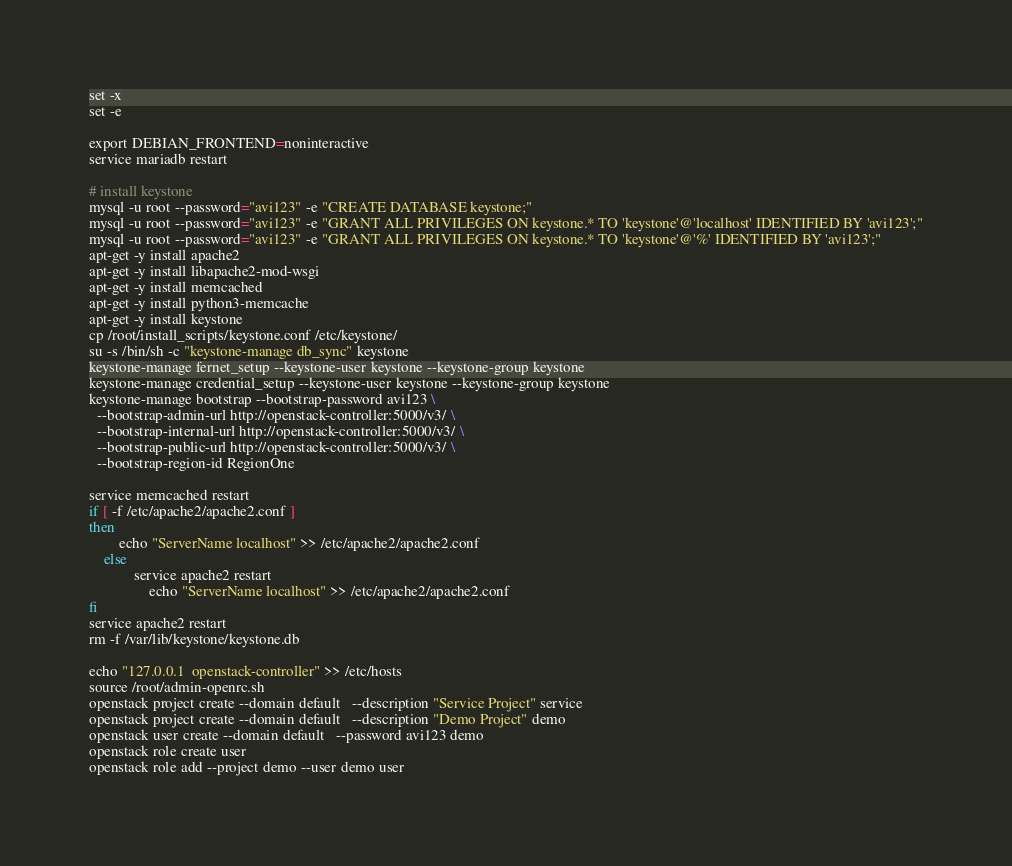Convert code to text. <code><loc_0><loc_0><loc_500><loc_500><_Bash_>set -x
set -e

export DEBIAN_FRONTEND=noninteractive
service mariadb restart

# install keystone
mysql -u root --password="avi123" -e "CREATE DATABASE keystone;"
mysql -u root --password="avi123" -e "GRANT ALL PRIVILEGES ON keystone.* TO 'keystone'@'localhost' IDENTIFIED BY 'avi123';"
mysql -u root --password="avi123" -e "GRANT ALL PRIVILEGES ON keystone.* TO 'keystone'@'%' IDENTIFIED BY 'avi123';"
apt-get -y install apache2
apt-get -y install libapache2-mod-wsgi
apt-get -y install memcached
apt-get -y install python3-memcache
apt-get -y install keystone
cp /root/install_scripts/keystone.conf /etc/keystone/
su -s /bin/sh -c "keystone-manage db_sync" keystone
keystone-manage fernet_setup --keystone-user keystone --keystone-group keystone
keystone-manage credential_setup --keystone-user keystone --keystone-group keystone
keystone-manage bootstrap --bootstrap-password avi123 \
  --bootstrap-admin-url http://openstack-controller:5000/v3/ \
  --bootstrap-internal-url http://openstack-controller:5000/v3/ \
  --bootstrap-public-url http://openstack-controller:5000/v3/ \
  --bootstrap-region-id RegionOne

service memcached restart
if [ -f /etc/apache2/apache2.conf ]
then
        echo "ServerName localhost" >> /etc/apache2/apache2.conf
    else
            service apache2 restart
                echo "ServerName localhost" >> /etc/apache2/apache2.conf
fi
service apache2 restart
rm -f /var/lib/keystone/keystone.db

echo "127.0.0.1  openstack-controller" >> /etc/hosts
source /root/admin-openrc.sh
openstack project create --domain default   --description "Service Project" service
openstack project create --domain default   --description "Demo Project" demo
openstack user create --domain default   --password avi123 demo
openstack role create user
openstack role add --project demo --user demo user
</code> 